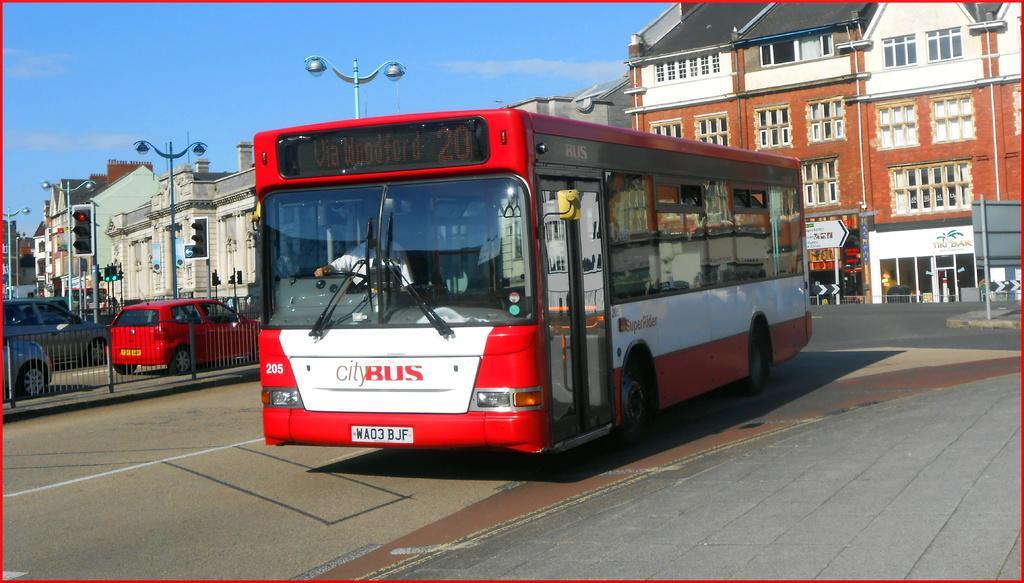Could you give a brief overview of what you see in this image? In the middle of this image, there is a bus in red and white color combination on the road. In the background, there are buildings, lights attached to the poles, there is a fence on a divider, outside this divider, there are other vehicles and there are clouds in the blue sky. 